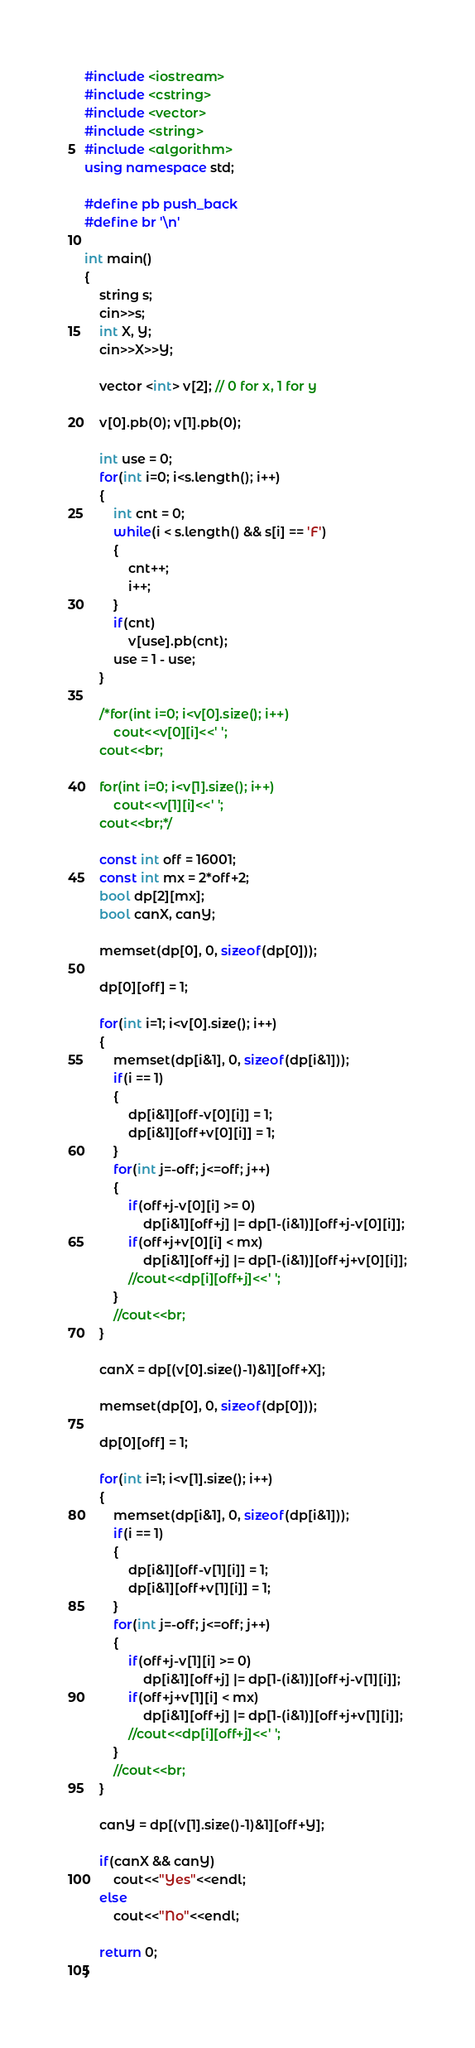Convert code to text. <code><loc_0><loc_0><loc_500><loc_500><_C++_>#include <iostream>
#include <cstring>
#include <vector>
#include <string>
#include <algorithm>
using namespace std;

#define pb push_back
#define br '\n'

int main()
{
    string s;
    cin>>s;
    int X, Y;
    cin>>X>>Y;

    vector <int> v[2]; // 0 for x, 1 for y

    v[0].pb(0); v[1].pb(0);

    int use = 0;
    for(int i=0; i<s.length(); i++)
    {
        int cnt = 0;
        while(i < s.length() && s[i] == 'F')
        {
            cnt++;
            i++;
        }
        if(cnt)
            v[use].pb(cnt);
        use = 1 - use;
    }

    /*for(int i=0; i<v[0].size(); i++)
        cout<<v[0][i]<<' ';
    cout<<br;

    for(int i=0; i<v[1].size(); i++)
        cout<<v[1][i]<<' ';
    cout<<br;*/

    const int off = 16001;
    const int mx = 2*off+2;
    bool dp[2][mx];
    bool canX, canY;

    memset(dp[0], 0, sizeof(dp[0]));

    dp[0][off] = 1;

    for(int i=1; i<v[0].size(); i++)
    {
        memset(dp[i&1], 0, sizeof(dp[i&1]));
        if(i == 1)
        {
            dp[i&1][off-v[0][i]] = 1;
            dp[i&1][off+v[0][i]] = 1;
        }
        for(int j=-off; j<=off; j++)
        {
            if(off+j-v[0][i] >= 0)
                dp[i&1][off+j] |= dp[1-(i&1)][off+j-v[0][i]];
            if(off+j+v[0][i] < mx)
                dp[i&1][off+j] |= dp[1-(i&1)][off+j+v[0][i]];
            //cout<<dp[i][off+j]<<' ';
        }
        //cout<<br;
    }

    canX = dp[(v[0].size()-1)&1][off+X];

    memset(dp[0], 0, sizeof(dp[0]));

    dp[0][off] = 1;

    for(int i=1; i<v[1].size(); i++)
    {
        memset(dp[i&1], 0, sizeof(dp[i&1]));
        if(i == 1)
        {
            dp[i&1][off-v[1][i]] = 1;
            dp[i&1][off+v[1][i]] = 1;
        }
        for(int j=-off; j<=off; j++)
        {
            if(off+j-v[1][i] >= 0)
                dp[i&1][off+j] |= dp[1-(i&1)][off+j-v[1][i]];
            if(off+j+v[1][i] < mx)
                dp[i&1][off+j] |= dp[1-(i&1)][off+j+v[1][i]];
            //cout<<dp[i][off+j]<<' ';
        }
        //cout<<br;
    }

    canY = dp[(v[1].size()-1)&1][off+Y];

    if(canX && canY)
        cout<<"Yes"<<endl;
    else
        cout<<"No"<<endl;

    return 0;
}

























</code> 